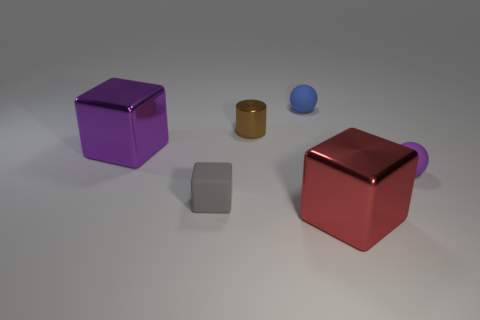Subtract all large cubes. How many cubes are left? 1 Add 2 brown things. How many objects exist? 8 Subtract all balls. How many objects are left? 4 Subtract all green cubes. Subtract all green cylinders. How many cubes are left? 3 Subtract all small blue rubber balls. Subtract all big purple objects. How many objects are left? 4 Add 1 tiny purple rubber balls. How many tiny purple rubber balls are left? 2 Add 3 gray matte things. How many gray matte things exist? 4 Subtract 0 brown spheres. How many objects are left? 6 